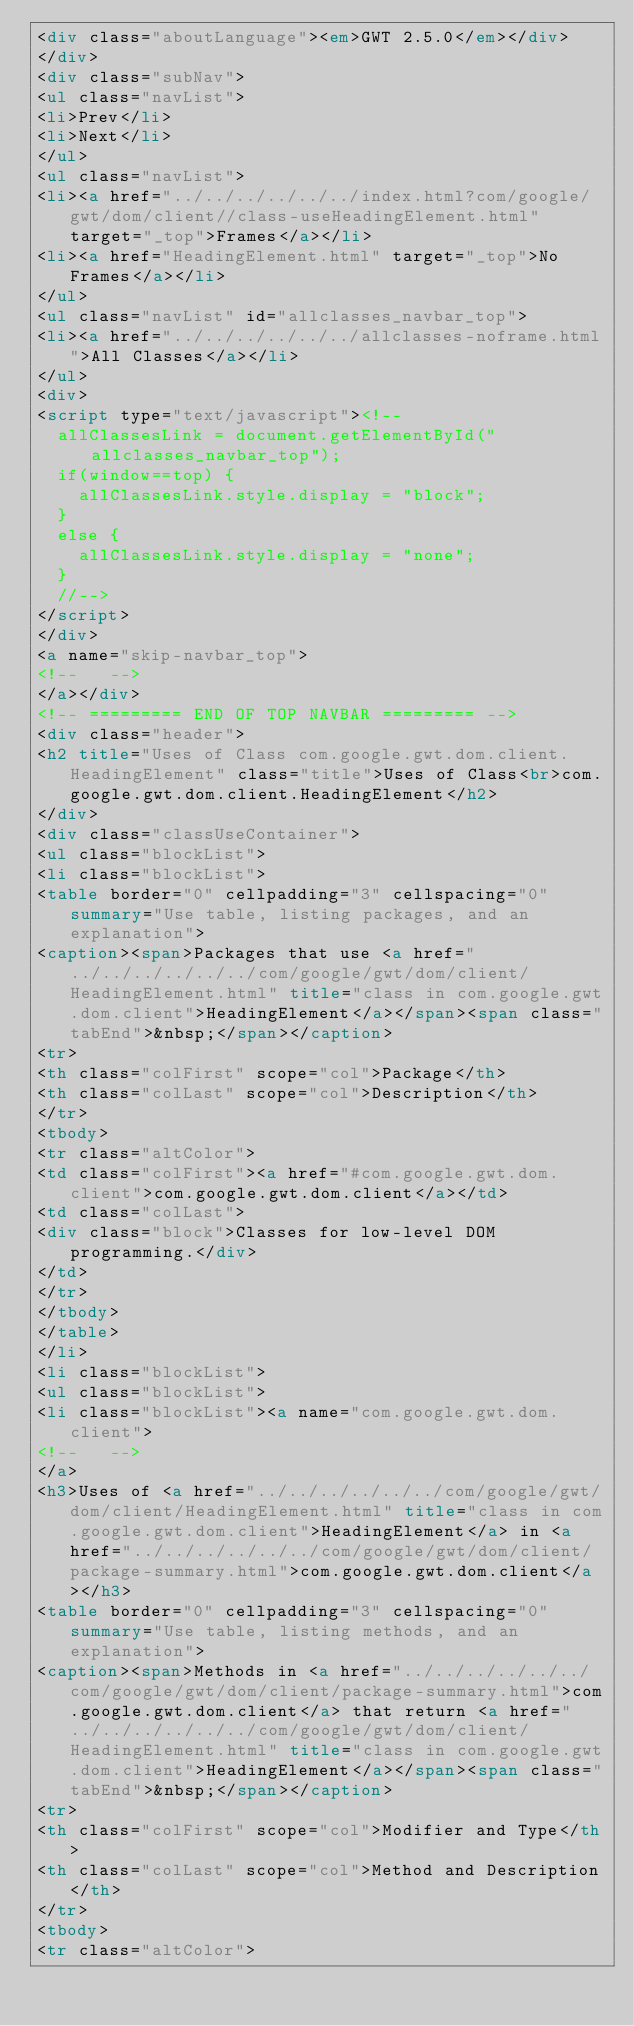<code> <loc_0><loc_0><loc_500><loc_500><_HTML_><div class="aboutLanguage"><em>GWT 2.5.0</em></div>
</div>
<div class="subNav">
<ul class="navList">
<li>Prev</li>
<li>Next</li>
</ul>
<ul class="navList">
<li><a href="../../../../../../index.html?com/google/gwt/dom/client//class-useHeadingElement.html" target="_top">Frames</a></li>
<li><a href="HeadingElement.html" target="_top">No Frames</a></li>
</ul>
<ul class="navList" id="allclasses_navbar_top">
<li><a href="../../../../../../allclasses-noframe.html">All Classes</a></li>
</ul>
<div>
<script type="text/javascript"><!--
  allClassesLink = document.getElementById("allclasses_navbar_top");
  if(window==top) {
    allClassesLink.style.display = "block";
  }
  else {
    allClassesLink.style.display = "none";
  }
  //-->
</script>
</div>
<a name="skip-navbar_top">
<!--   -->
</a></div>
<!-- ========= END OF TOP NAVBAR ========= -->
<div class="header">
<h2 title="Uses of Class com.google.gwt.dom.client.HeadingElement" class="title">Uses of Class<br>com.google.gwt.dom.client.HeadingElement</h2>
</div>
<div class="classUseContainer">
<ul class="blockList">
<li class="blockList">
<table border="0" cellpadding="3" cellspacing="0" summary="Use table, listing packages, and an explanation">
<caption><span>Packages that use <a href="../../../../../../com/google/gwt/dom/client/HeadingElement.html" title="class in com.google.gwt.dom.client">HeadingElement</a></span><span class="tabEnd">&nbsp;</span></caption>
<tr>
<th class="colFirst" scope="col">Package</th>
<th class="colLast" scope="col">Description</th>
</tr>
<tbody>
<tr class="altColor">
<td class="colFirst"><a href="#com.google.gwt.dom.client">com.google.gwt.dom.client</a></td>
<td class="colLast">
<div class="block">Classes for low-level DOM programming.</div>
</td>
</tr>
</tbody>
</table>
</li>
<li class="blockList">
<ul class="blockList">
<li class="blockList"><a name="com.google.gwt.dom.client">
<!--   -->
</a>
<h3>Uses of <a href="../../../../../../com/google/gwt/dom/client/HeadingElement.html" title="class in com.google.gwt.dom.client">HeadingElement</a> in <a href="../../../../../../com/google/gwt/dom/client/package-summary.html">com.google.gwt.dom.client</a></h3>
<table border="0" cellpadding="3" cellspacing="0" summary="Use table, listing methods, and an explanation">
<caption><span>Methods in <a href="../../../../../../com/google/gwt/dom/client/package-summary.html">com.google.gwt.dom.client</a> that return <a href="../../../../../../com/google/gwt/dom/client/HeadingElement.html" title="class in com.google.gwt.dom.client">HeadingElement</a></span><span class="tabEnd">&nbsp;</span></caption>
<tr>
<th class="colFirst" scope="col">Modifier and Type</th>
<th class="colLast" scope="col">Method and Description</th>
</tr>
<tbody>
<tr class="altColor"></code> 